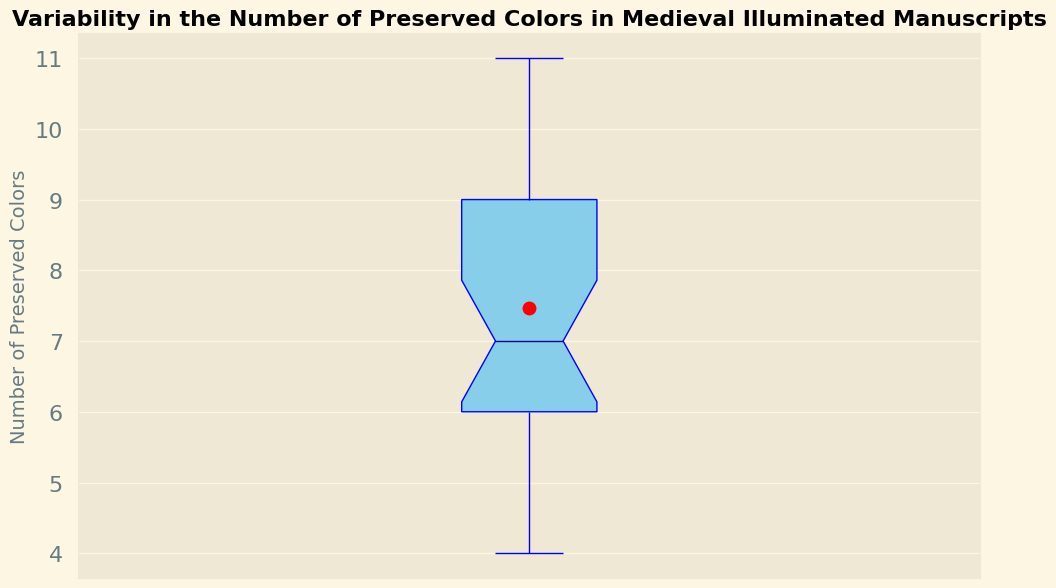What is the median number of preserved colors? The median is depicted by the dark blue line inside the box. The value is 7.
Answer: 7 What is the mean number of preserved colors? The mean is shown by the red dot within the box. The value is approximately 7.5.
Answer: 7.5 Which manuscript has the highest number of preserved colors and what is that value? The highest preserved color count is shown at the top whisker of the box plot, which corresponds to 11. There are two manuscripts with this value.
Answer: 11 What is the interquartile range (IQR) of the number of preserved colors? The IQR is the range between the lower quartile (Q1) and the upper quartile (Q3) values of the box. In this plot, Q1 is 6 and Q3 is 9. So, the IQR is 9 - 6.
Answer: 3 Are there any outliers in the number of preserved colors? Outliers are typically shown as individual points beyond the whiskers. This box plot does not display any such points; thus, there are no outliers.
Answer: No Which number of preserved colors appears most frequently in the manuscripts? This can be determined by looking at the distribution of data. The mode is 7, as it occurs most often within the interquartile range.
Answer: 7 What is the range of the number of preserved colors? The range is the difference between the maximum and minimum values. For this data, the maximum value is 11 and the minimum is 4, so the range is 11 - 4.
Answer: 7 How does the third quartile (Q3) compare to the mean? The third quartile is higher than the mean. Q3 is 9, while the mean is around 7.5.
Answer: Q3 is higher Which value represents the 25th percentile, and what does it signify? The 25th percentile is marked by the bottom of the box (Q1), which is 6. This means 25% of the manuscripts have 6 or fewer preserved colors.
Answer: 6 Are the mean and median significantly different? The mean and median can be compared visually. The mean is around 7.5 and the median is 7; these values are close, indicating a relatively symmetric distribution.
Answer: No 